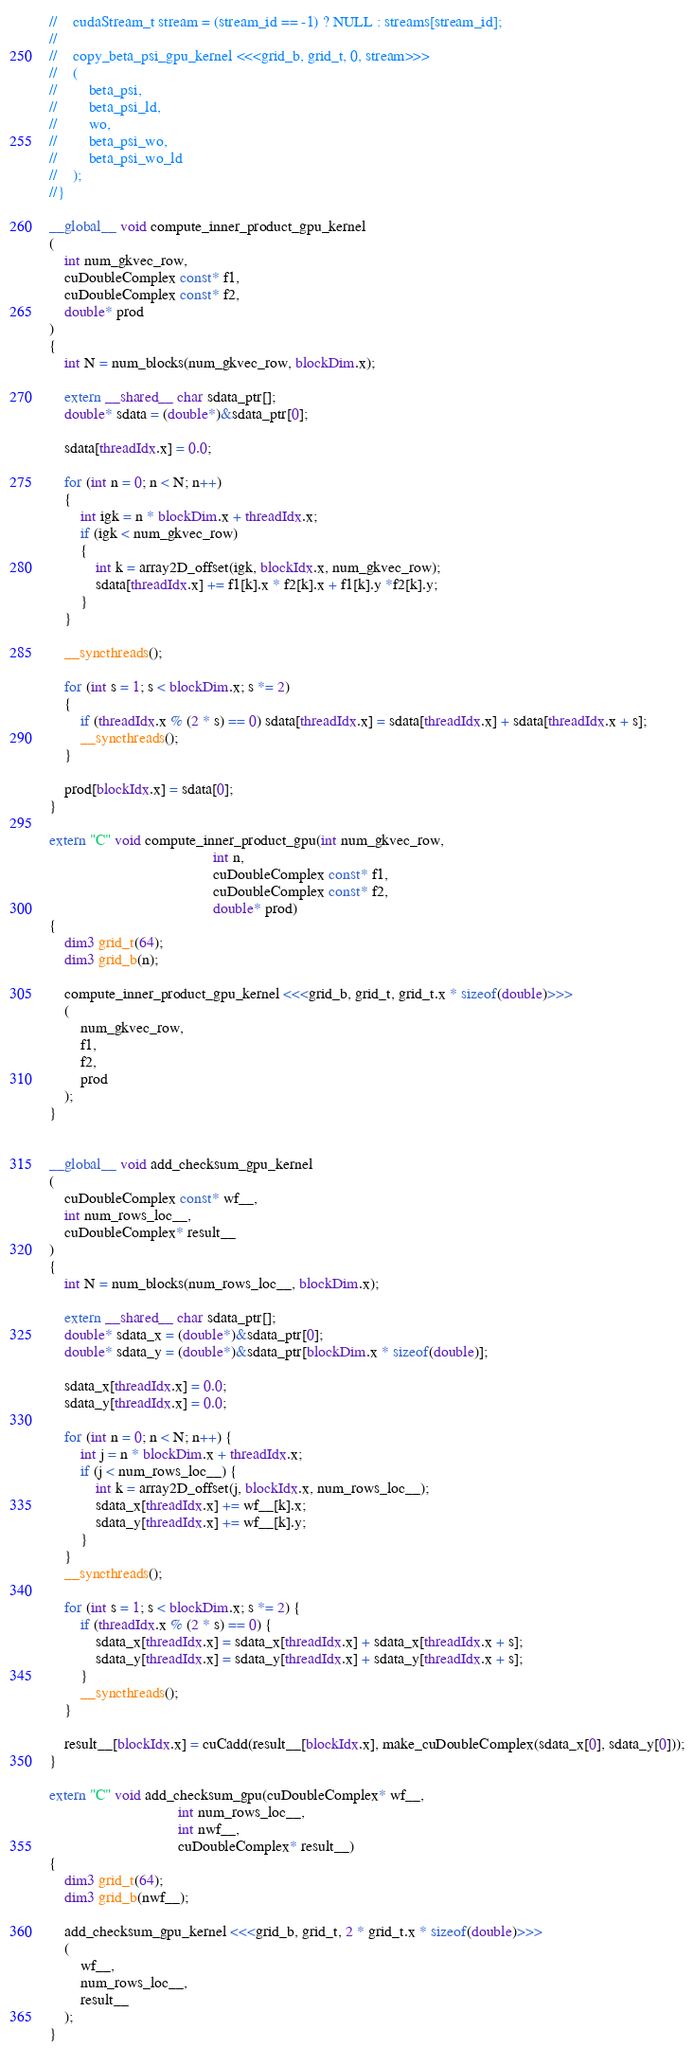Convert code to text. <code><loc_0><loc_0><loc_500><loc_500><_Cuda_>//    cudaStream_t stream = (stream_id == -1) ? NULL : streams[stream_id];
//    
//    copy_beta_psi_gpu_kernel <<<grid_b, grid_t, 0, stream>>>
//    (
//        beta_psi,
//        beta_psi_ld,
//        wo,
//        beta_psi_wo,
//        beta_psi_wo_ld
//    );
//}

__global__ void compute_inner_product_gpu_kernel
(
    int num_gkvec_row,
    cuDoubleComplex const* f1,
    cuDoubleComplex const* f2,
    double* prod
)
{
    int N = num_blocks(num_gkvec_row, blockDim.x);

    extern __shared__ char sdata_ptr[];
    double* sdata = (double*)&sdata_ptr[0];

    sdata[threadIdx.x] = 0.0;

    for (int n = 0; n < N; n++)
    {
        int igk = n * blockDim.x + threadIdx.x;
        if (igk < num_gkvec_row)
        {
            int k = array2D_offset(igk, blockIdx.x, num_gkvec_row);
            sdata[threadIdx.x] += f1[k].x * f2[k].x + f1[k].y *f2[k].y;
        }
    }

    __syncthreads();

    for (int s = 1; s < blockDim.x; s *= 2) 
    {
        if (threadIdx.x % (2 * s) == 0) sdata[threadIdx.x] = sdata[threadIdx.x] + sdata[threadIdx.x + s];
        __syncthreads();
    }
    
    prod[blockIdx.x] = sdata[0];
}

extern "C" void compute_inner_product_gpu(int num_gkvec_row,
                                          int n,
                                          cuDoubleComplex const* f1,
                                          cuDoubleComplex const* f2,
                                          double* prod)
{
    dim3 grid_t(64);
    dim3 grid_b(n);

    compute_inner_product_gpu_kernel <<<grid_b, grid_t, grid_t.x * sizeof(double)>>>
    (
        num_gkvec_row,
        f1,
        f2,
        prod
    );
}


__global__ void add_checksum_gpu_kernel
(
    cuDoubleComplex const* wf__,
    int num_rows_loc__,
    cuDoubleComplex* result__
)
{
    int N = num_blocks(num_rows_loc__, blockDim.x);

    extern __shared__ char sdata_ptr[];
    double* sdata_x = (double*)&sdata_ptr[0];
    double* sdata_y = (double*)&sdata_ptr[blockDim.x * sizeof(double)];

    sdata_x[threadIdx.x] = 0.0;
    sdata_y[threadIdx.x] = 0.0;

    for (int n = 0; n < N; n++) {
        int j = n * blockDim.x + threadIdx.x;
        if (j < num_rows_loc__) {
            int k = array2D_offset(j, blockIdx.x, num_rows_loc__);
            sdata_x[threadIdx.x] += wf__[k].x;
            sdata_y[threadIdx.x] += wf__[k].y;
        }
    }
    __syncthreads();

    for (int s = 1; s < blockDim.x; s *= 2) {
        if (threadIdx.x % (2 * s) == 0) {
            sdata_x[threadIdx.x] = sdata_x[threadIdx.x] + sdata_x[threadIdx.x + s];
            sdata_y[threadIdx.x] = sdata_y[threadIdx.x] + sdata_y[threadIdx.x + s];
        }
        __syncthreads();
    }

    result__[blockIdx.x] = cuCadd(result__[blockIdx.x], make_cuDoubleComplex(sdata_x[0], sdata_y[0]));
}

extern "C" void add_checksum_gpu(cuDoubleComplex* wf__,
                                 int num_rows_loc__,
                                 int nwf__,
                                 cuDoubleComplex* result__)
{
    dim3 grid_t(64);
    dim3 grid_b(nwf__);

    add_checksum_gpu_kernel <<<grid_b, grid_t, 2 * grid_t.x * sizeof(double)>>>
    (
        wf__,
        num_rows_loc__,
        result__
    );
}
</code> 